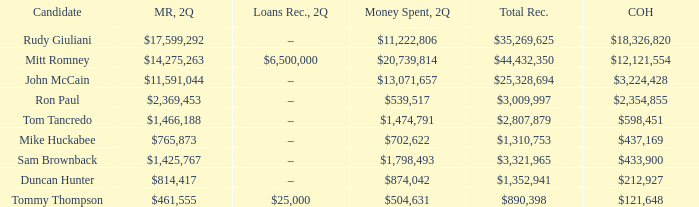Tell me the money raised when 2Q has total receipts of $890,398 $461,555. 